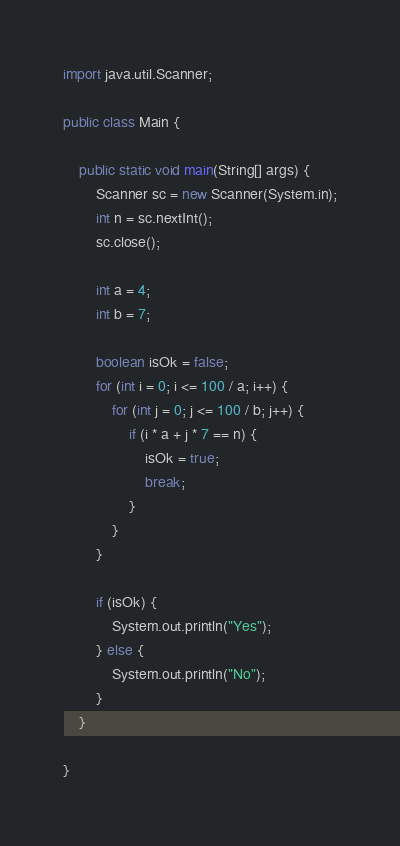Convert code to text. <code><loc_0><loc_0><loc_500><loc_500><_Java_>import java.util.Scanner;

public class Main {

    public static void main(String[] args) {
        Scanner sc = new Scanner(System.in);
        int n = sc.nextInt();
        sc.close();

        int a = 4;
        int b = 7;

        boolean isOk = false;
        for (int i = 0; i <= 100 / a; i++) {
            for (int j = 0; j <= 100 / b; j++) {
                if (i * a + j * 7 == n) {
                    isOk = true;
                    break;
                }
            }
        }

        if (isOk) {
            System.out.println("Yes");
        } else {
            System.out.println("No");
        }
    }

}
</code> 